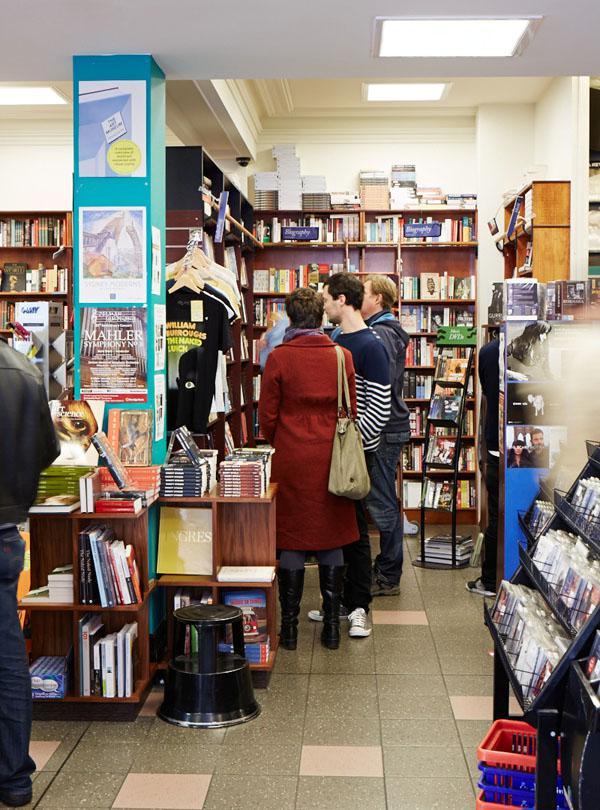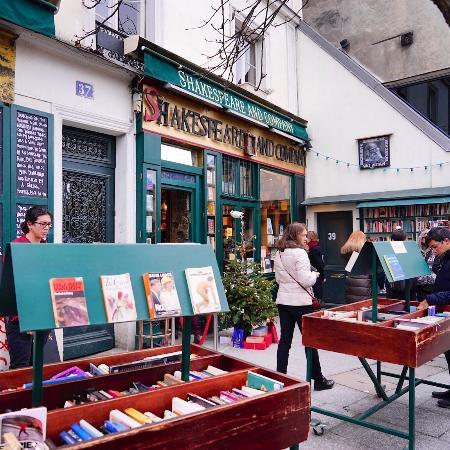The first image is the image on the left, the second image is the image on the right. Evaluate the accuracy of this statement regarding the images: "There is 1 or more person(s) browsing the book selections.". Is it true? Answer yes or no. Yes. The first image is the image on the left, the second image is the image on the right. Considering the images on both sides, is "There is a person in at least one of the photos." valid? Answer yes or no. Yes. 